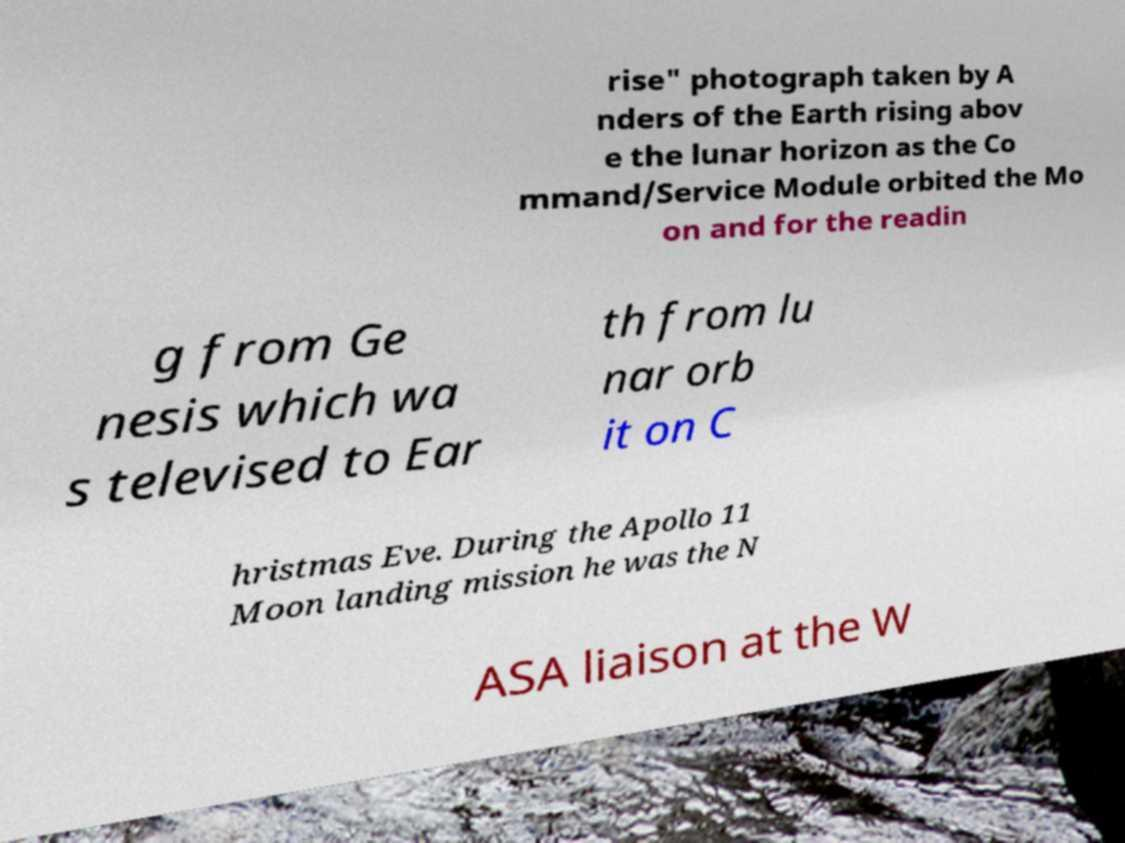Could you extract and type out the text from this image? rise" photograph taken by A nders of the Earth rising abov e the lunar horizon as the Co mmand/Service Module orbited the Mo on and for the readin g from Ge nesis which wa s televised to Ear th from lu nar orb it on C hristmas Eve. During the Apollo 11 Moon landing mission he was the N ASA liaison at the W 